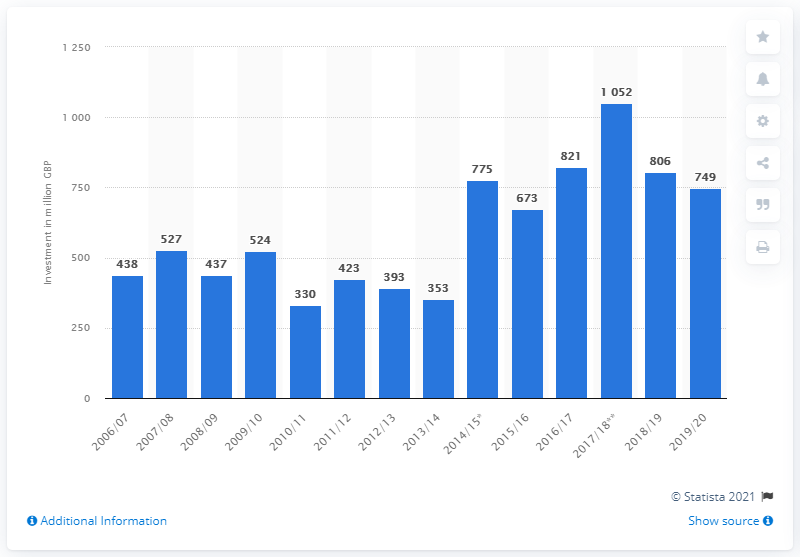Indicate a few pertinent items in this graphic. The amount of private investment in rolling stock for the financial year 2019/20 was 749.. 